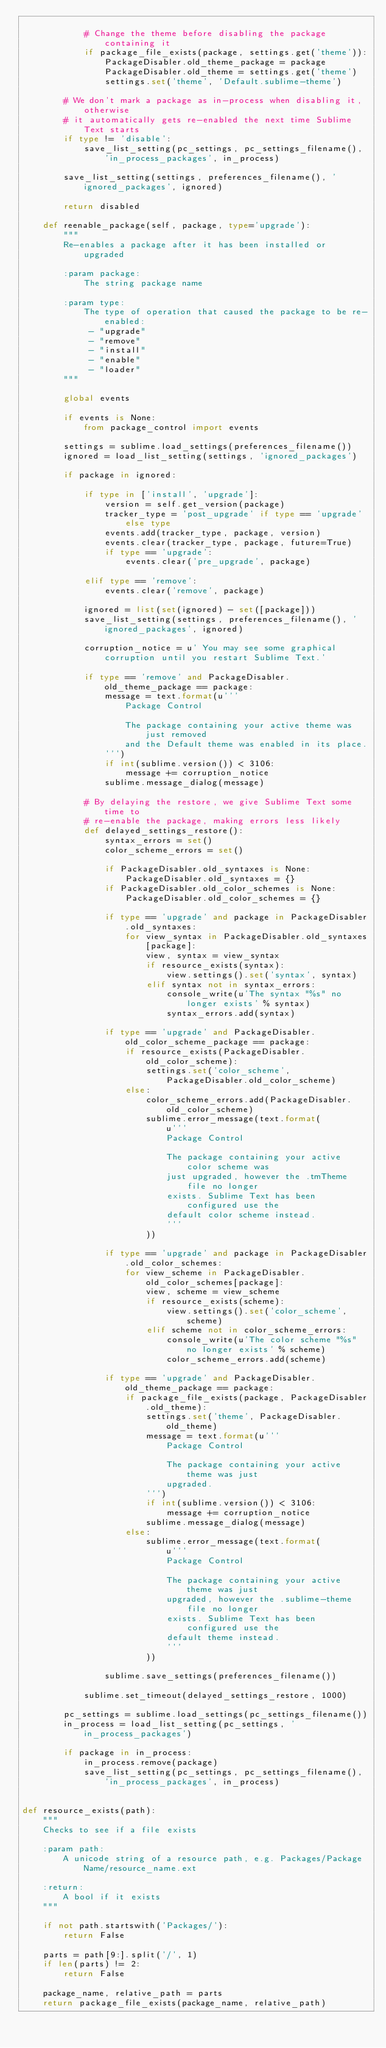Convert code to text. <code><loc_0><loc_0><loc_500><loc_500><_Python_>
            # Change the theme before disabling the package containing it
            if package_file_exists(package, settings.get('theme')):
                PackageDisabler.old_theme_package = package
                PackageDisabler.old_theme = settings.get('theme')
                settings.set('theme', 'Default.sublime-theme')

        # We don't mark a package as in-process when disabling it, otherwise
        # it automatically gets re-enabled the next time Sublime Text starts
        if type != 'disable':
            save_list_setting(pc_settings, pc_settings_filename(), 'in_process_packages', in_process)

        save_list_setting(settings, preferences_filename(), 'ignored_packages', ignored)

        return disabled

    def reenable_package(self, package, type='upgrade'):
        """
        Re-enables a package after it has been installed or upgraded

        :param package:
            The string package name

        :param type:
            The type of operation that caused the package to be re-enabled:
             - "upgrade"
             - "remove"
             - "install"
             - "enable"
             - "loader"
        """

        global events

        if events is None:
            from package_control import events

        settings = sublime.load_settings(preferences_filename())
        ignored = load_list_setting(settings, 'ignored_packages')

        if package in ignored:

            if type in ['install', 'upgrade']:
                version = self.get_version(package)
                tracker_type = 'post_upgrade' if type == 'upgrade' else type
                events.add(tracker_type, package, version)
                events.clear(tracker_type, package, future=True)
                if type == 'upgrade':
                    events.clear('pre_upgrade', package)

            elif type == 'remove':
                events.clear('remove', package)

            ignored = list(set(ignored) - set([package]))
            save_list_setting(settings, preferences_filename(), 'ignored_packages', ignored)

            corruption_notice = u' You may see some graphical corruption until you restart Sublime Text.'

            if type == 'remove' and PackageDisabler.old_theme_package == package:
                message = text.format(u'''
                    Package Control

                    The package containing your active theme was just removed
                    and the Default theme was enabled in its place.
                ''')
                if int(sublime.version()) < 3106:
                    message += corruption_notice
                sublime.message_dialog(message)

            # By delaying the restore, we give Sublime Text some time to
            # re-enable the package, making errors less likely
            def delayed_settings_restore():
                syntax_errors = set()
                color_scheme_errors = set()

                if PackageDisabler.old_syntaxes is None:
                    PackageDisabler.old_syntaxes = {}
                if PackageDisabler.old_color_schemes is None:
                    PackageDisabler.old_color_schemes = {}

                if type == 'upgrade' and package in PackageDisabler.old_syntaxes:
                    for view_syntax in PackageDisabler.old_syntaxes[package]:
                        view, syntax = view_syntax
                        if resource_exists(syntax):
                            view.settings().set('syntax', syntax)
                        elif syntax not in syntax_errors:
                            console_write(u'The syntax "%s" no longer exists' % syntax)
                            syntax_errors.add(syntax)

                if type == 'upgrade' and PackageDisabler.old_color_scheme_package == package:
                    if resource_exists(PackageDisabler.old_color_scheme):
                        settings.set('color_scheme', PackageDisabler.old_color_scheme)
                    else:
                        color_scheme_errors.add(PackageDisabler.old_color_scheme)
                        sublime.error_message(text.format(
                            u'''
                            Package Control

                            The package containing your active color scheme was
                            just upgraded, however the .tmTheme file no longer
                            exists. Sublime Text has been configured use the
                            default color scheme instead.
                            '''
                        ))

                if type == 'upgrade' and package in PackageDisabler.old_color_schemes:
                    for view_scheme in PackageDisabler.old_color_schemes[package]:
                        view, scheme = view_scheme
                        if resource_exists(scheme):
                            view.settings().set('color_scheme', scheme)
                        elif scheme not in color_scheme_errors:
                            console_write(u'The color scheme "%s" no longer exists' % scheme)
                            color_scheme_errors.add(scheme)

                if type == 'upgrade' and PackageDisabler.old_theme_package == package:
                    if package_file_exists(package, PackageDisabler.old_theme):
                        settings.set('theme', PackageDisabler.old_theme)
                        message = text.format(u'''
                            Package Control

                            The package containing your active theme was just
                            upgraded.
                        ''')
                        if int(sublime.version()) < 3106:
                            message += corruption_notice
                        sublime.message_dialog(message)
                    else:
                        sublime.error_message(text.format(
                            u'''
                            Package Control

                            The package containing your active theme was just
                            upgraded, however the .sublime-theme file no longer
                            exists. Sublime Text has been configured use the
                            default theme instead.
                            '''
                        ))

                sublime.save_settings(preferences_filename())

            sublime.set_timeout(delayed_settings_restore, 1000)

        pc_settings = sublime.load_settings(pc_settings_filename())
        in_process = load_list_setting(pc_settings, 'in_process_packages')

        if package in in_process:
            in_process.remove(package)
            save_list_setting(pc_settings, pc_settings_filename(), 'in_process_packages', in_process)


def resource_exists(path):
    """
    Checks to see if a file exists

    :param path:
        A unicode string of a resource path, e.g. Packages/Package Name/resource_name.ext

    :return:
        A bool if it exists
    """

    if not path.startswith('Packages/'):
        return False

    parts = path[9:].split('/', 1)
    if len(parts) != 2:
        return False

    package_name, relative_path = parts
    return package_file_exists(package_name, relative_path)
</code> 